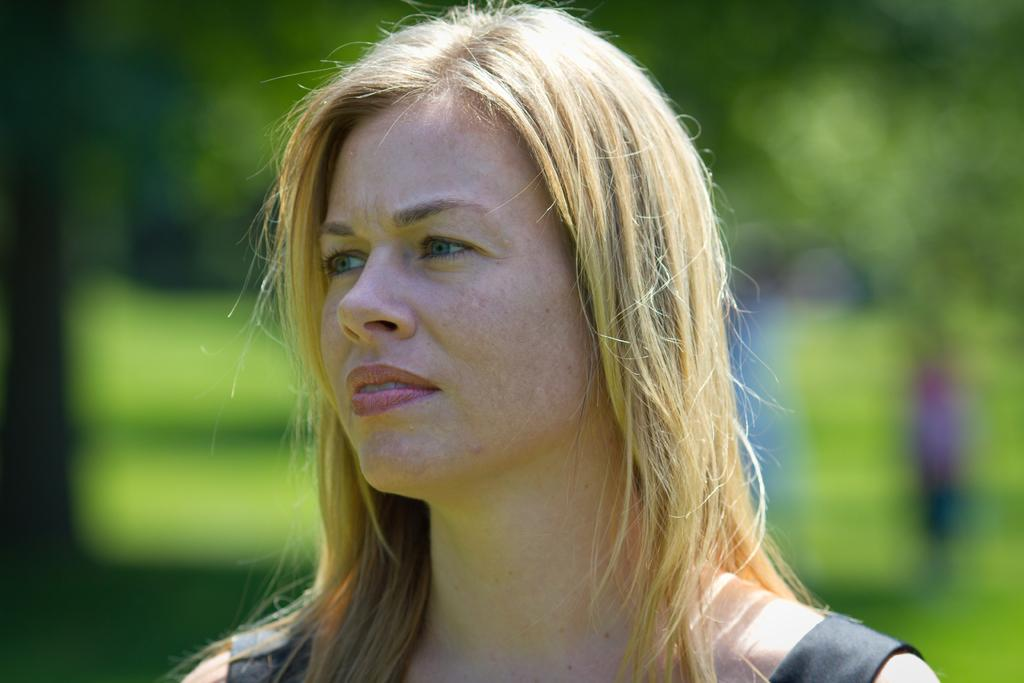Who is the main subject in the picture? There is a woman in the picture. What can be observed about the background of the image? The background of the picture is blurry. How many rabbits are visible in the picture? There are no rabbits present in the image. What type of expansion is taking place in the picture? There is no expansion visible in the image; it features a woman with a blurry background. 